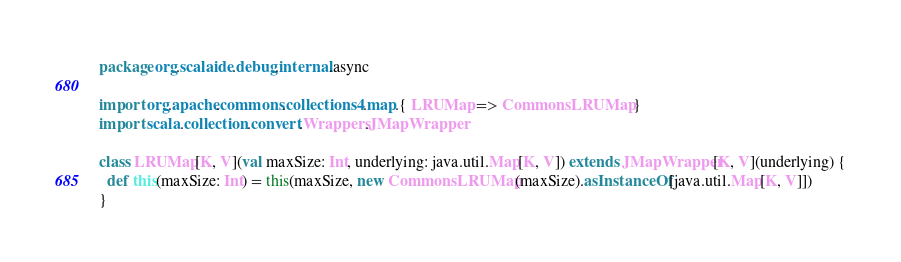<code> <loc_0><loc_0><loc_500><loc_500><_Scala_>package org.scalaide.debug.internal.async

import org.apache.commons.collections4.map.{ LRUMap => CommonsLRUMap }
import scala.collection.convert.Wrappers.JMapWrapper

class LRUMap[K, V](val maxSize: Int, underlying: java.util.Map[K, V]) extends JMapWrapper[K, V](underlying) {
  def this(maxSize: Int) = this(maxSize, new CommonsLRUMap(maxSize).asInstanceOf[java.util.Map[K, V]])
}

</code> 